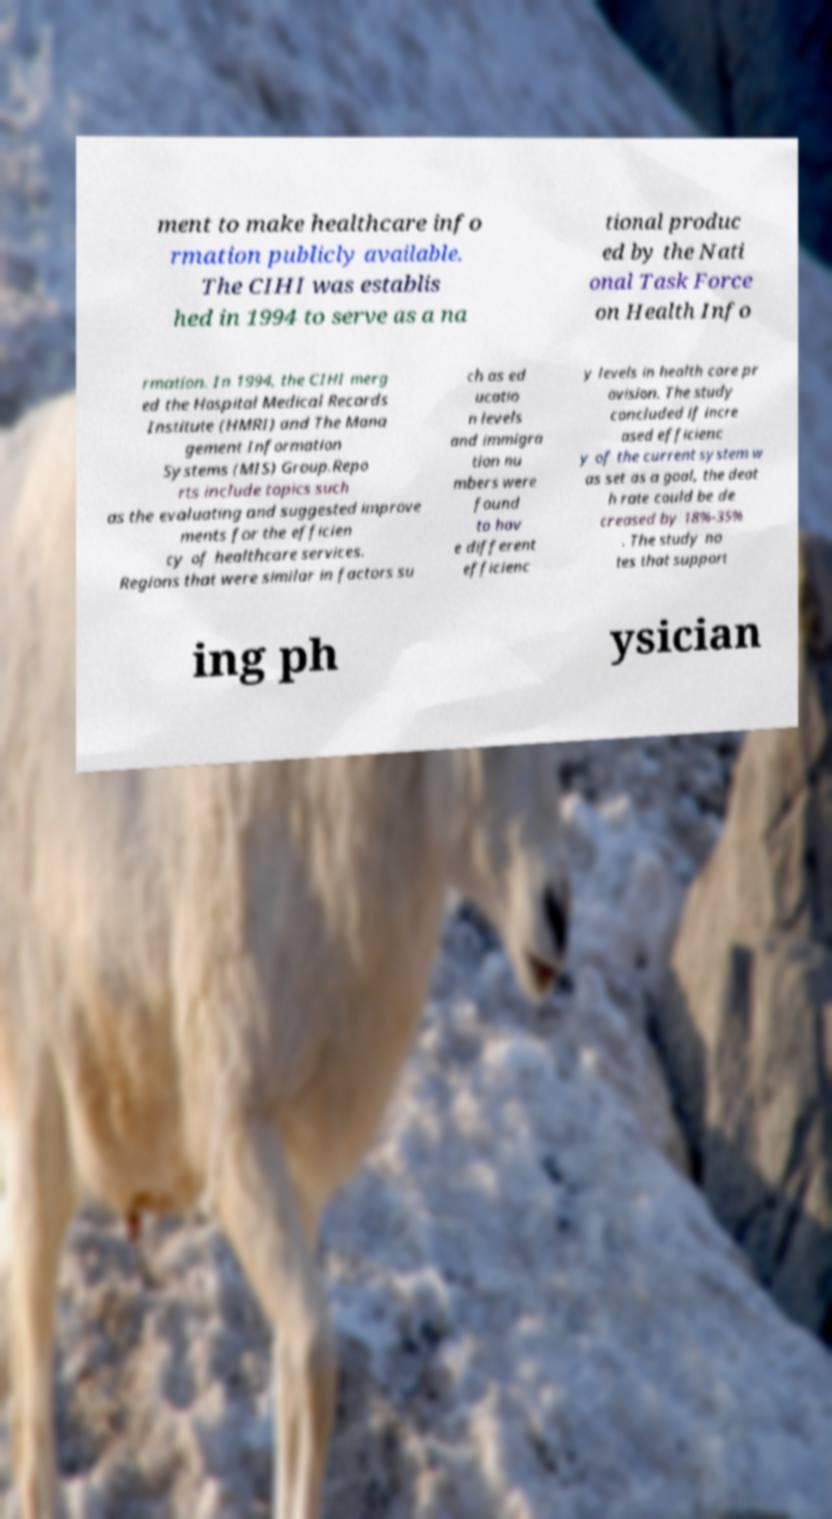Please read and relay the text visible in this image. What does it say? ment to make healthcare info rmation publicly available. The CIHI was establis hed in 1994 to serve as a na tional produc ed by the Nati onal Task Force on Health Info rmation. In 1994, the CIHI merg ed the Hospital Medical Records Institute (HMRI) and The Mana gement Information Systems (MIS) Group.Repo rts include topics such as the evaluating and suggested improve ments for the efficien cy of healthcare services. Regions that were similar in factors su ch as ed ucatio n levels and immigra tion nu mbers were found to hav e different efficienc y levels in health care pr ovision. The study concluded if incre ased efficienc y of the current system w as set as a goal, the deat h rate could be de creased by 18%-35% . The study no tes that support ing ph ysician 